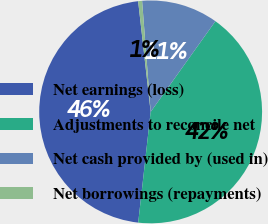<chart> <loc_0><loc_0><loc_500><loc_500><pie_chart><fcel>Net earnings (loss)<fcel>Adjustments to reconcile net<fcel>Net cash provided by (used in)<fcel>Net borrowings (repayments)<nl><fcel>46.42%<fcel>41.91%<fcel>11.09%<fcel>0.57%<nl></chart> 